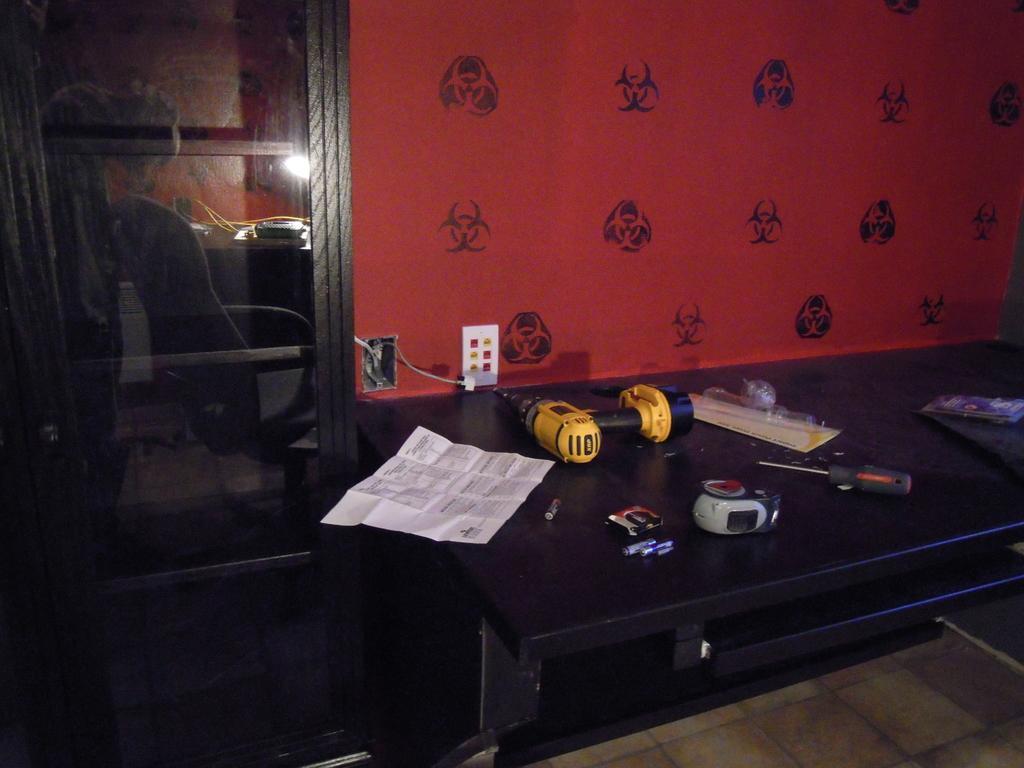Please provide a concise description of this image. There are tools a paper and other items on a desk in the foreground area of the image, it seems like a rack on the left side, it seems like a wall in the background. 